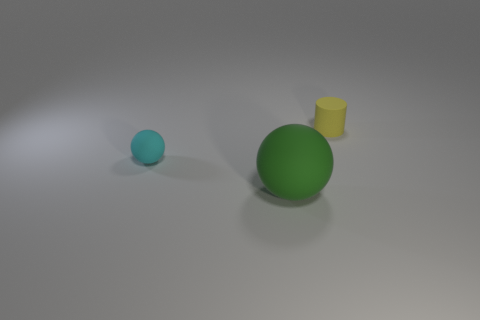Describe the textures visible in the image. The objects seem to have a smooth surface, and there's a subtle texture on the ground, suggesting a slightly uneven material, perhaps a matte finish. 